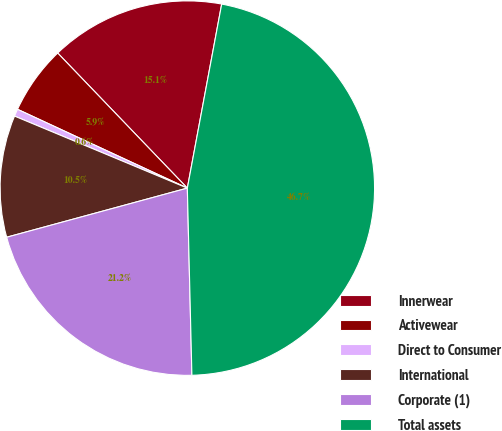Convert chart. <chart><loc_0><loc_0><loc_500><loc_500><pie_chart><fcel>Innerwear<fcel>Activewear<fcel>Direct to Consumer<fcel>International<fcel>Corporate (1)<fcel>Total assets<nl><fcel>15.11%<fcel>5.91%<fcel>0.63%<fcel>10.51%<fcel>21.16%<fcel>46.67%<nl></chart> 